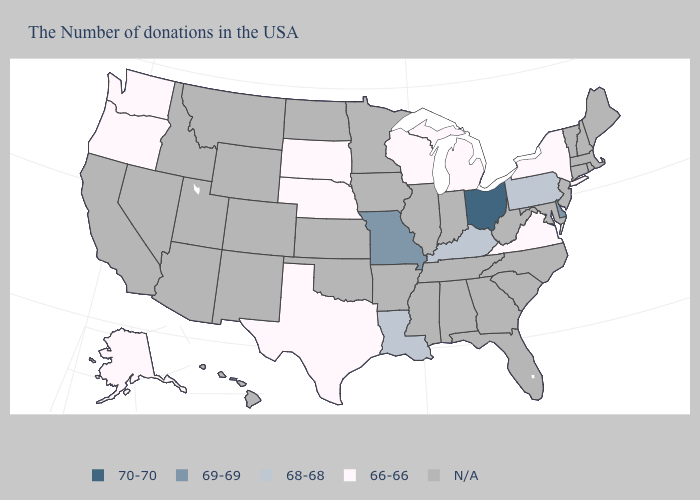Name the states that have a value in the range 66-66?
Concise answer only. New York, Virginia, Michigan, Wisconsin, Nebraska, Texas, South Dakota, Washington, Oregon, Alaska. Does South Dakota have the lowest value in the MidWest?
Give a very brief answer. Yes. Does the first symbol in the legend represent the smallest category?
Quick response, please. No. Does Nebraska have the lowest value in the USA?
Give a very brief answer. Yes. Does the first symbol in the legend represent the smallest category?
Give a very brief answer. No. What is the highest value in the USA?
Write a very short answer. 70-70. What is the value of Idaho?
Answer briefly. N/A. Name the states that have a value in the range 70-70?
Be succinct. Ohio. What is the value of North Carolina?
Be succinct. N/A. What is the value of North Carolina?
Quick response, please. N/A. What is the value of West Virginia?
Concise answer only. N/A. Does Ohio have the lowest value in the MidWest?
Write a very short answer. No. Name the states that have a value in the range 66-66?
Be succinct. New York, Virginia, Michigan, Wisconsin, Nebraska, Texas, South Dakota, Washington, Oregon, Alaska. 